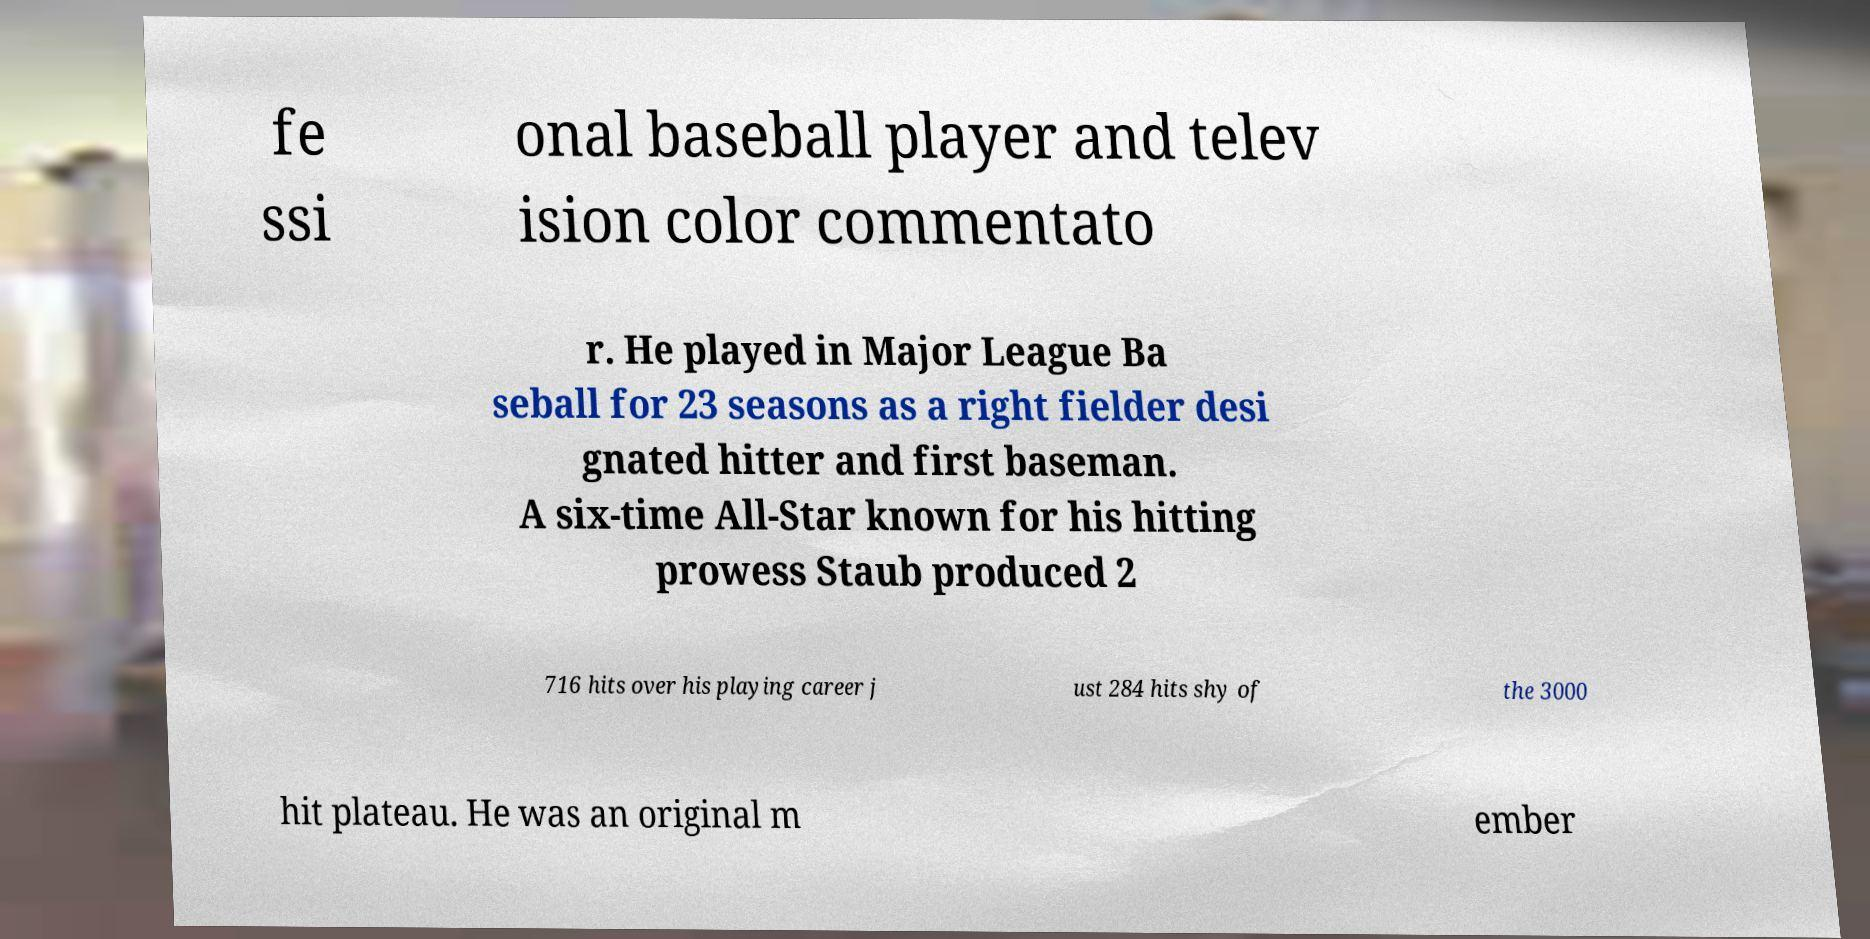Could you assist in decoding the text presented in this image and type it out clearly? fe ssi onal baseball player and telev ision color commentato r. He played in Major League Ba seball for 23 seasons as a right fielder desi gnated hitter and first baseman. A six-time All-Star known for his hitting prowess Staub produced 2 716 hits over his playing career j ust 284 hits shy of the 3000 hit plateau. He was an original m ember 